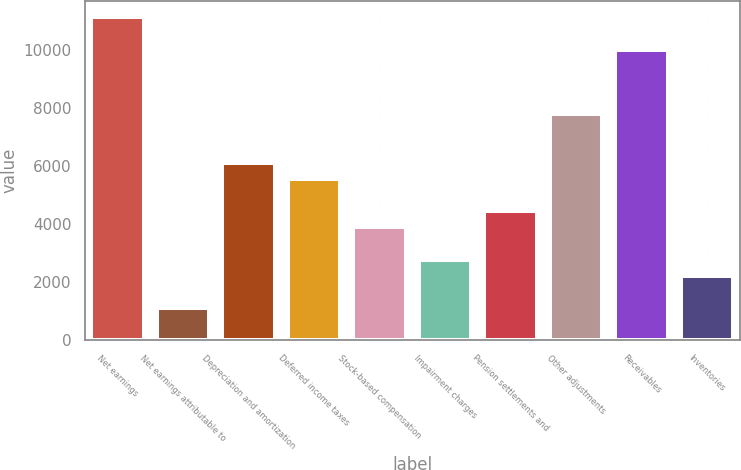Convert chart. <chart><loc_0><loc_0><loc_500><loc_500><bar_chart><fcel>Net earnings<fcel>Net earnings attributable to<fcel>Depreciation and amortization<fcel>Deferred income taxes<fcel>Stock-based compensation<fcel>Impairment charges<fcel>Pension settlements and<fcel>Other adjustments<fcel>Receivables<fcel>Inventories<nl><fcel>11140<fcel>1115.8<fcel>6127.9<fcel>5571<fcel>3900.3<fcel>2786.5<fcel>4457.2<fcel>7798.6<fcel>10026.2<fcel>2229.6<nl></chart> 